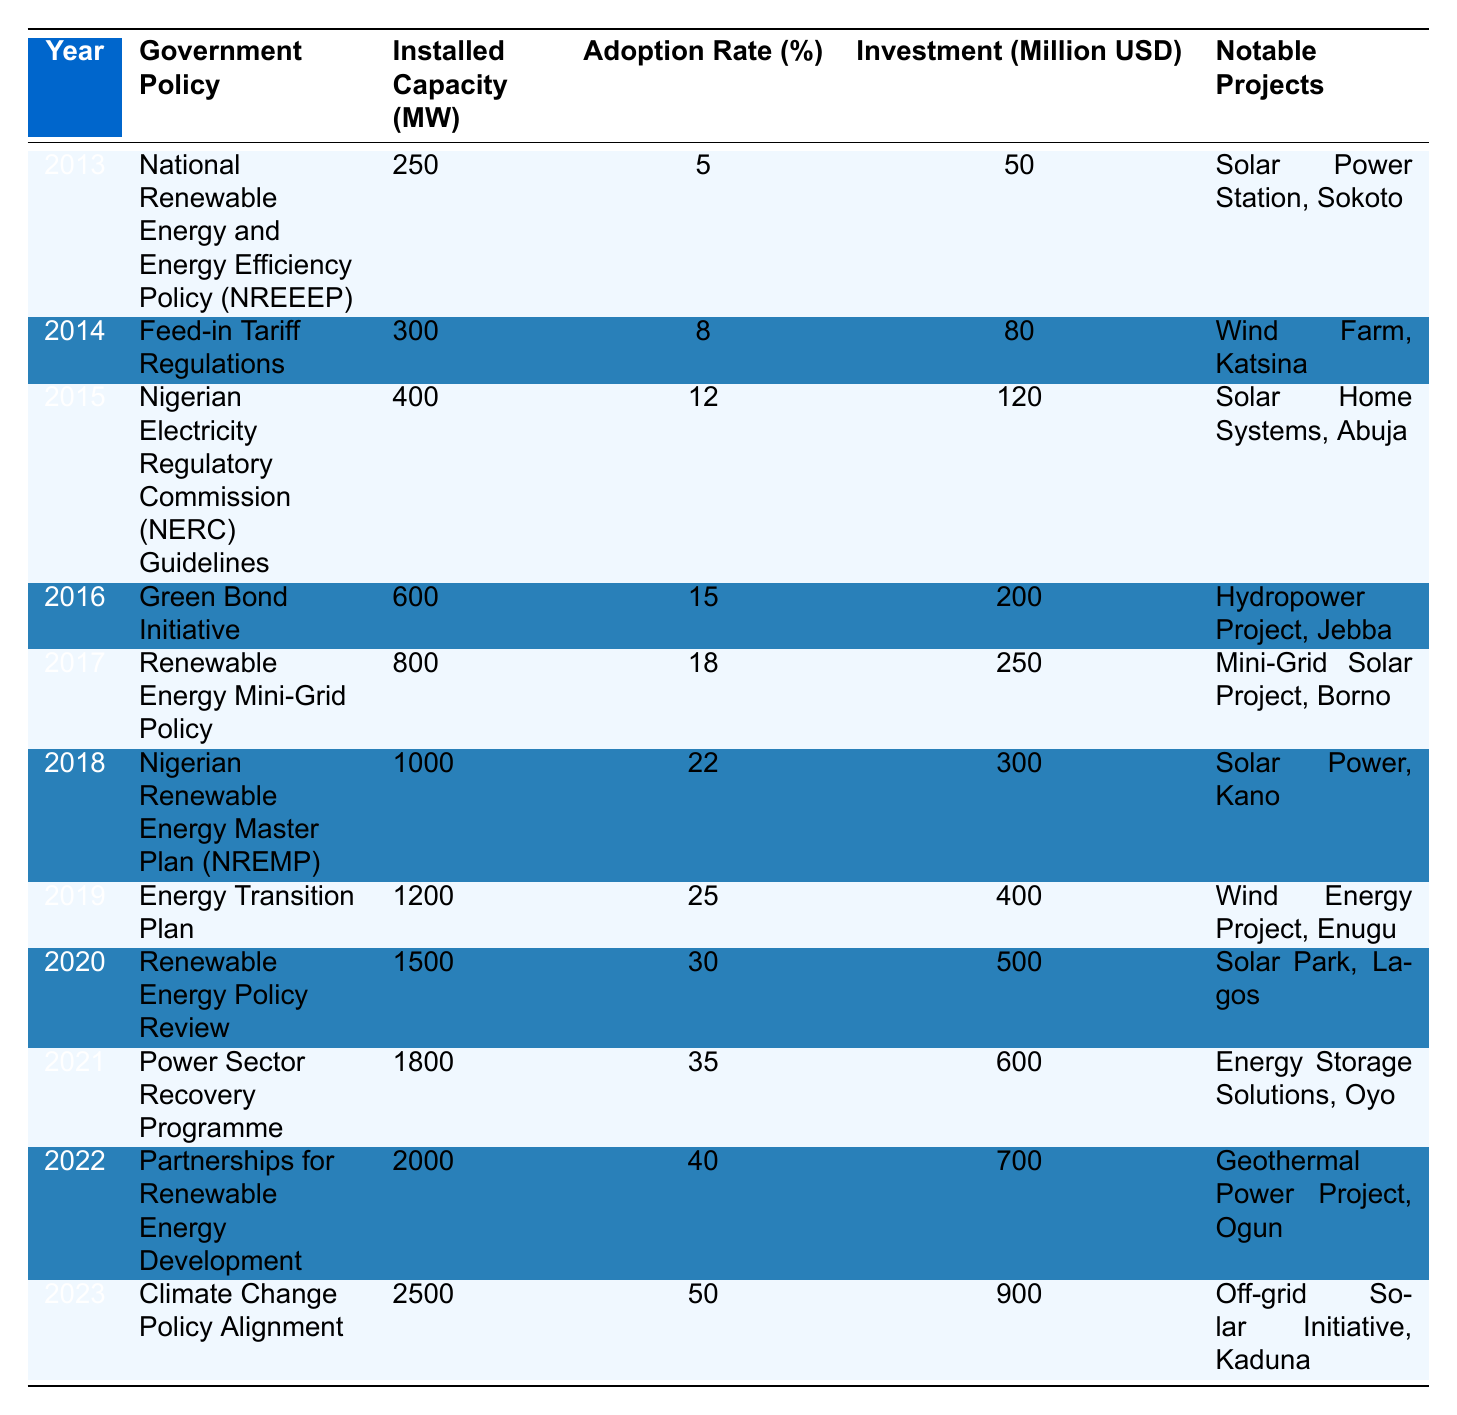What was the adoption rate in 2015? The table shows that in 2015, the adoption rate percentage is listed as 12%.
Answer: 12% Which government policy was implemented in 2020? According to the table, the government policy implemented in 2020 is the "Renewable Energy Policy Review."
Answer: Renewable Energy Policy Review What is the total installed capacity from 2013 to 2023? To find the total installed capacity, sum the values: 250 + 300 + 400 + 600 + 800 + 1000 + 1200 + 1500 + 1800 + 2000 + 2500 = 10600 MW.
Answer: 10600 MW Did the investment in renewable energy exceed $800 million in any year? Yes, in the years 2022 and 2023, the investments are $700 million and $900 million respectively, indicating that the investment did exceed $800 million in 2023.
Answer: Yes What was the average adoption rate from 2013 to 2022? To calculate the average adoption rate, sum the adoption rates: (5 + 8 + 12 + 15 + 18 + 22 + 25 + 30 + 35 + 40) =  205%. There are 10 years, so the average is 205% / 10 = 20.5%.
Answer: 20.5% 